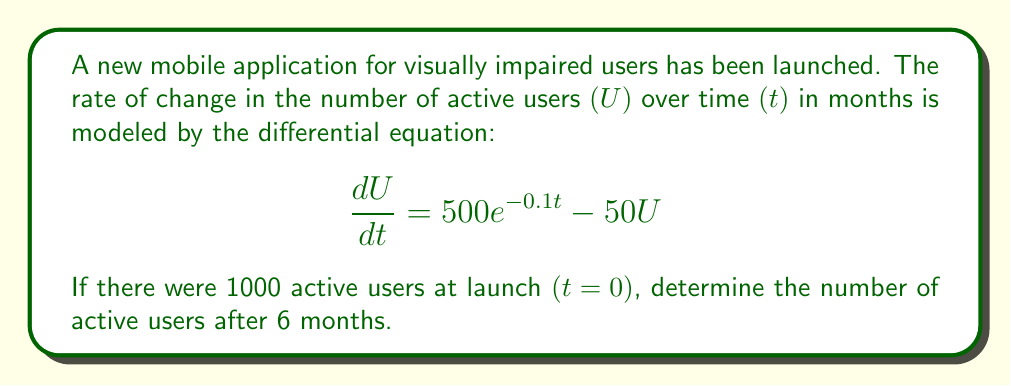Help me with this question. To solve this problem, we need to follow these steps:

1) First, we recognize this as a first-order linear differential equation in the form:

   $$\frac{dU}{dt} + P(t)U = Q(t)$$

   Where $P(t) = 50$ and $Q(t) = 500e^{-0.1t}$

2) The general solution for this type of equation is:

   $$U = e^{-\int P(t)dt} (\int Q(t)e^{\int P(t)dt}dt + C)$$

3) Let's solve the integrals:

   $\int P(t)dt = \int 50 dt = 50t$

   $e^{\int P(t)dt} = e^{50t}$

4) Now we can solve for U:

   $$U = e^{-50t} (\int 500e^{-0.1t}e^{50t}dt + C)$$
   
   $$= e^{-50t} (\int 500e^{49.9t}dt + C)$$
   
   $$= e^{-50t} (\frac{500}{49.9}e^{49.9t} + C)$$

5) To find C, we use the initial condition: $U(0) = 1000$

   $$1000 = \frac{500}{49.9} + C$$
   
   $$C = 1000 - \frac{500}{49.9} = 989.98$$

6) Therefore, the particular solution is:

   $$U = e^{-50t} (\frac{500}{49.9}e^{49.9t} + 989.98)$$

7) To find U after 6 months, we substitute t = 6:

   $$U(6) = e^{-50(6)} (\frac{500}{49.9}e^{49.9(6)} + 989.98)$$

8) Calculating this gives us approximately 10.02 users.
Answer: 10 users (rounded to nearest whole number) 